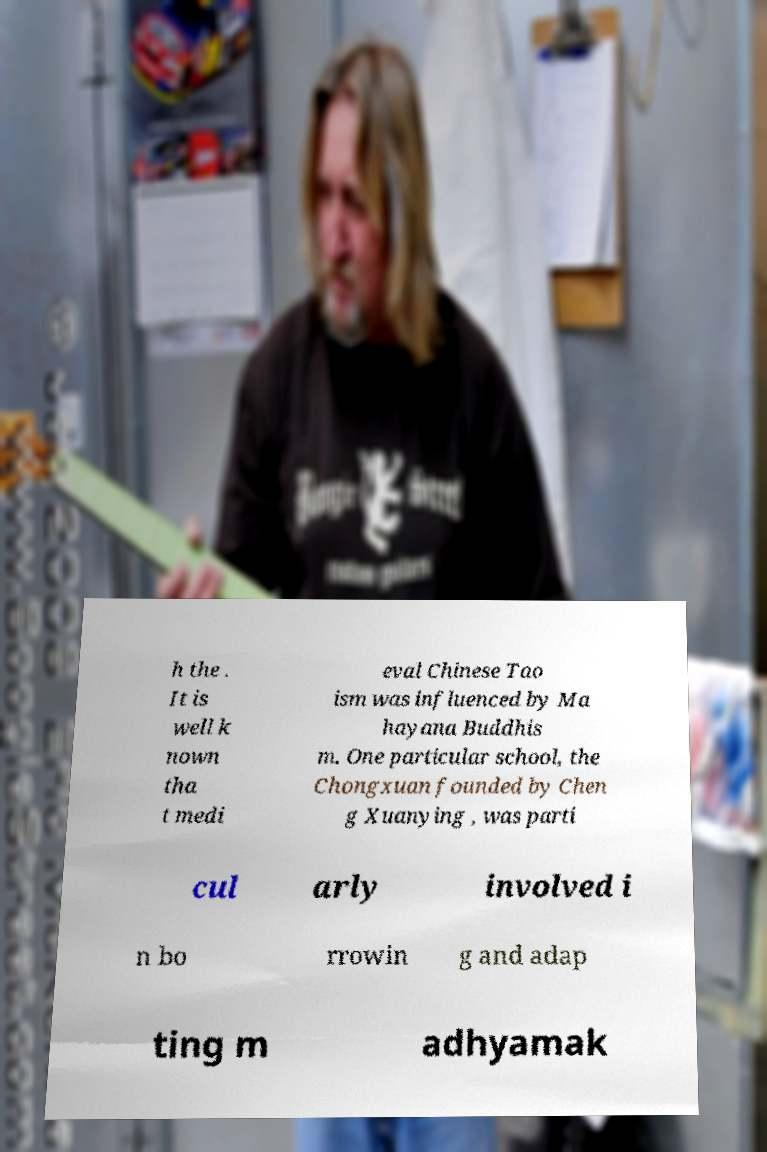Please identify and transcribe the text found in this image. h the . It is well k nown tha t medi eval Chinese Tao ism was influenced by Ma hayana Buddhis m. One particular school, the Chongxuan founded by Chen g Xuanying , was parti cul arly involved i n bo rrowin g and adap ting m adhyamak 